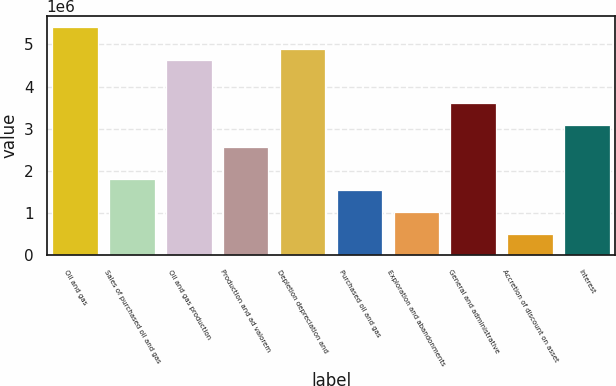Convert chart. <chart><loc_0><loc_0><loc_500><loc_500><bar_chart><fcel>Oil and gas<fcel>Sales of purchased oil and gas<fcel>Oil and gas production<fcel>Production and ad valorem<fcel>Depletion depreciation and<fcel>Purchased oil and gas<fcel>Exploration and abandonments<fcel>General and administrative<fcel>Accretion of discount on asset<fcel>Interest<nl><fcel>5.40815e+06<fcel>1.80272e+06<fcel>4.63556e+06<fcel>2.57531e+06<fcel>4.89309e+06<fcel>1.54519e+06<fcel>1.03013e+06<fcel>3.60543e+06<fcel>515063<fcel>3.09037e+06<nl></chart> 